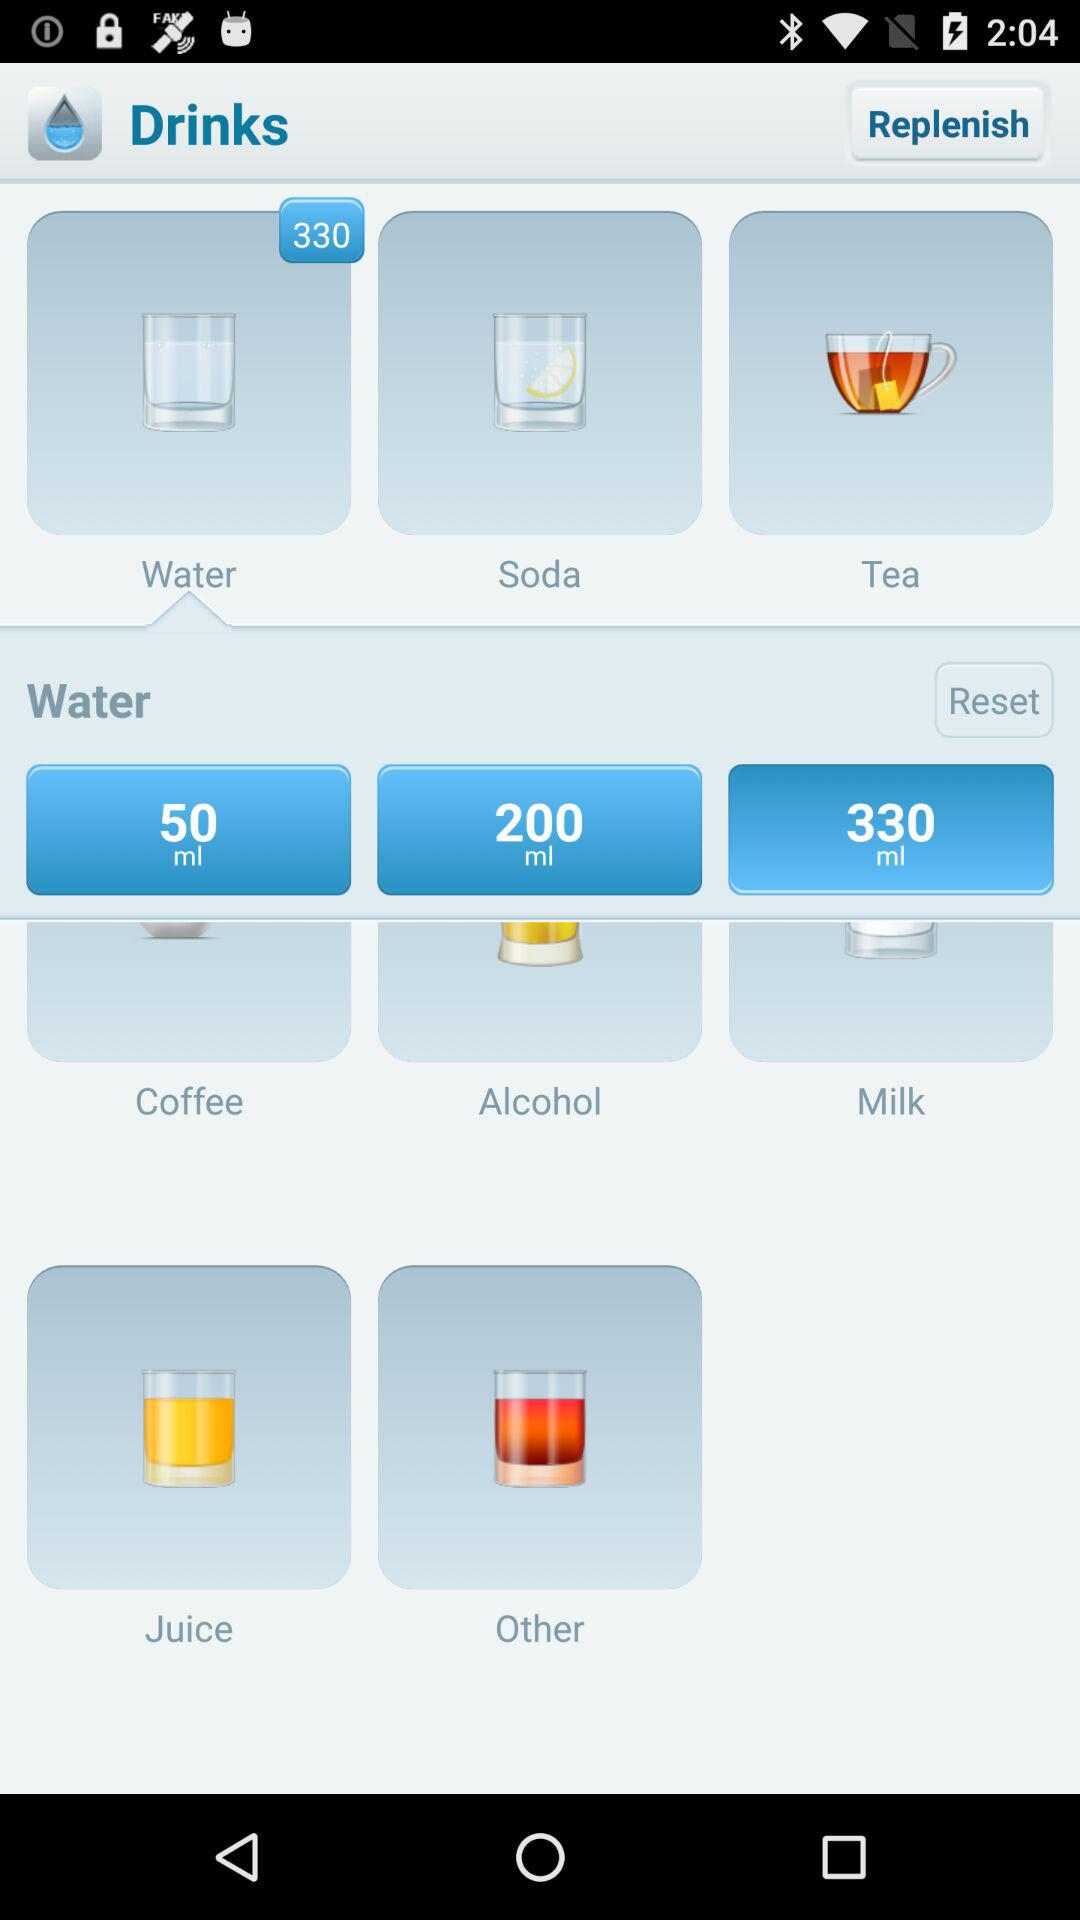How much milk do you have? You have 330 ml of milk. 